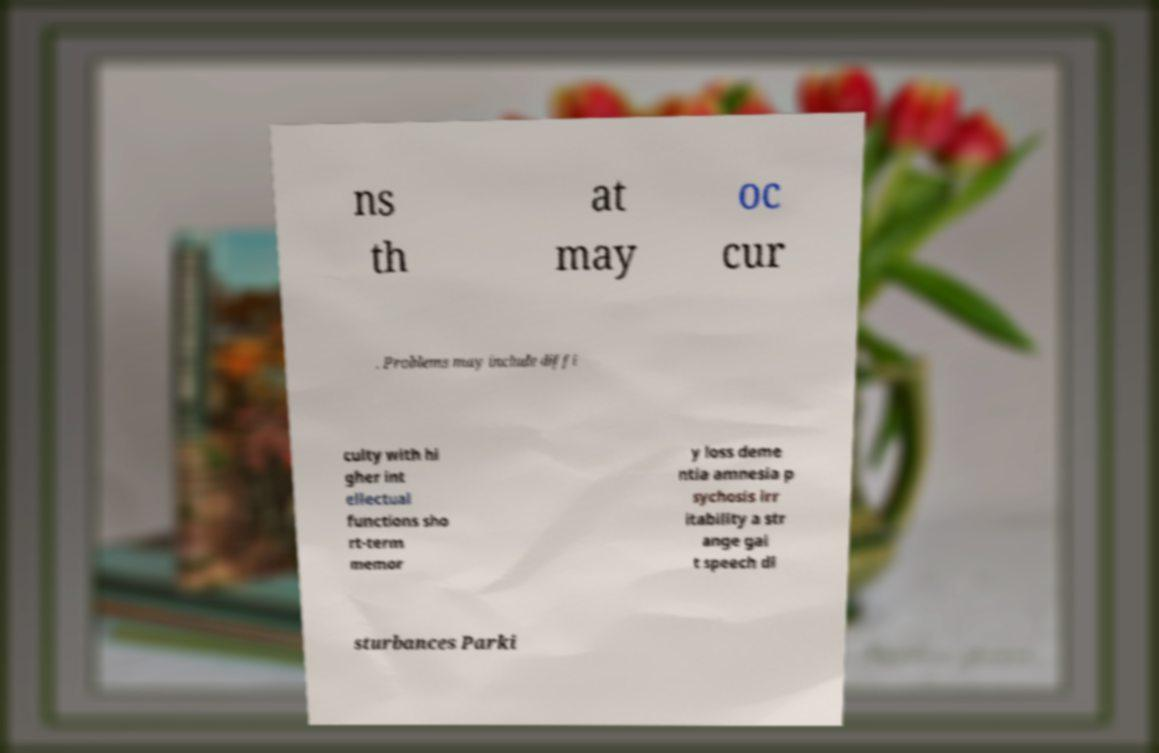What messages or text are displayed in this image? I need them in a readable, typed format. ns th at may oc cur . Problems may include diffi culty with hi gher int ellectual functions sho rt-term memor y loss deme ntia amnesia p sychosis irr itability a str ange gai t speech di sturbances Parki 